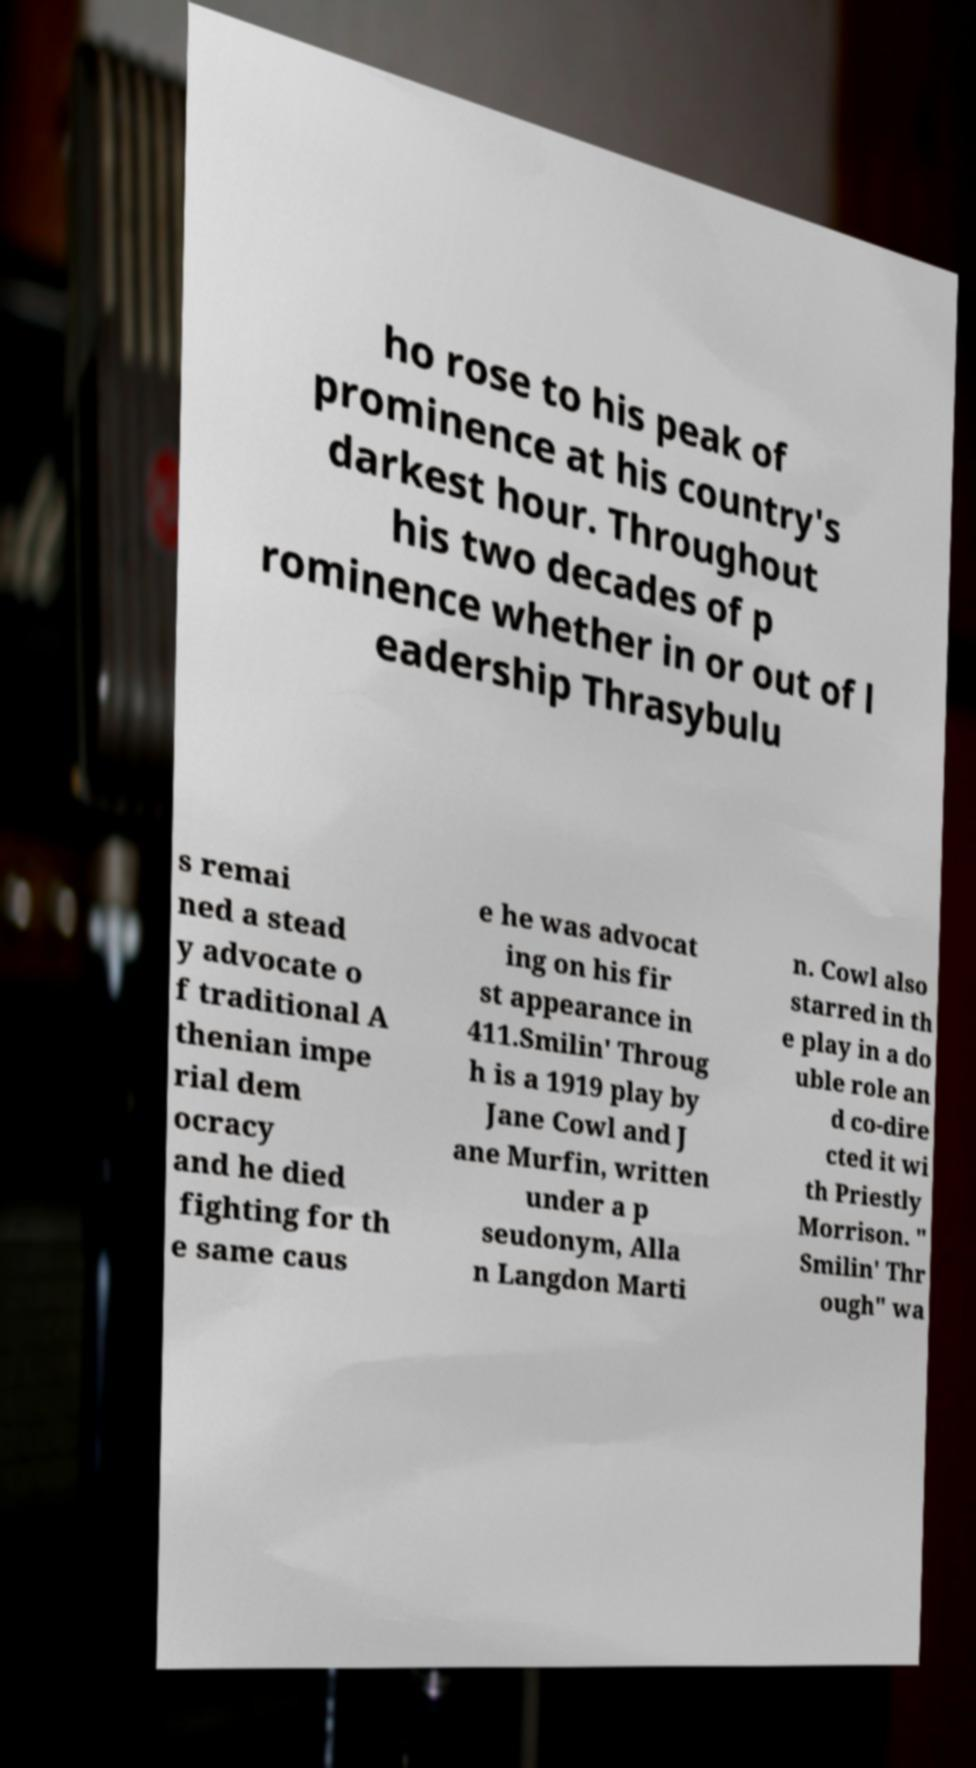There's text embedded in this image that I need extracted. Can you transcribe it verbatim? ho rose to his peak of prominence at his country's darkest hour. Throughout his two decades of p rominence whether in or out of l eadership Thrasybulu s remai ned a stead y advocate o f traditional A thenian impe rial dem ocracy and he died fighting for th e same caus e he was advocat ing on his fir st appearance in 411.Smilin' Throug h is a 1919 play by Jane Cowl and J ane Murfin, written under a p seudonym, Alla n Langdon Marti n. Cowl also starred in th e play in a do uble role an d co-dire cted it wi th Priestly Morrison. " Smilin' Thr ough" wa 